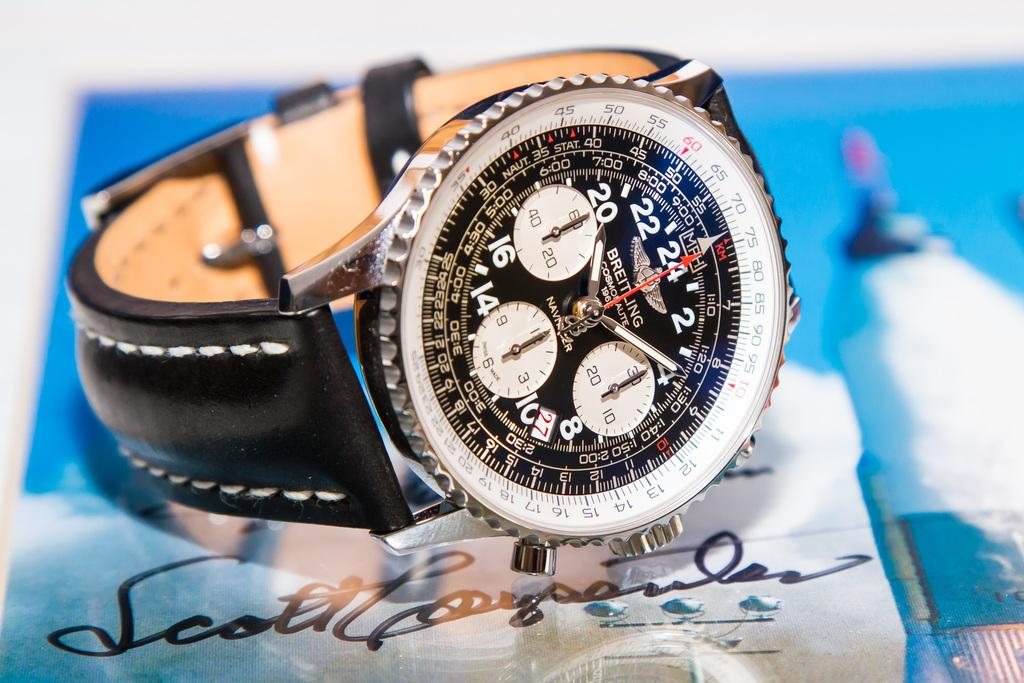Provide a one-sentence caption for the provided image. A watch lies sideways on top of Scott's autograph. 